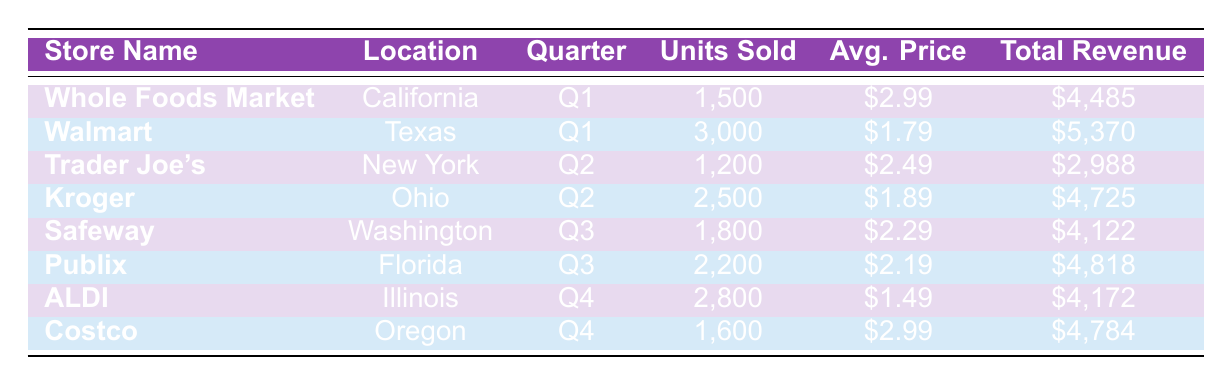What is the total revenue for Walmart in Q1? In the table, the row for Walmart in Q1 shows a total revenue of $5,370.
Answer: 5,370 Which store sold the highest number of units in Q3? By examining the rows for Q3, Publix sold 2,200 units while Safeway sold 1,800 units. Therefore, Publix sold more units than any other store in that quarter.
Answer: Publix What is the average price per unit for aubergines sold at Kroger in Q2? The table lists the average price per unit for Kroger in Q2 as $1.89.
Answer: 1.89 How many units were sold across all stores in Q4? For Q4, ALDI sold 2,800 units and Costco sold 1,600 units. Adding those figures, 2,800 + 1,600 equals 4,400 units sold in total during Q4.
Answer: 4,400 Is the average price per unit for aubergines sold at Whole Foods Market in Q1 higher than that at ALDI in Q4? Whole Foods Market had an average price of $2.99 in Q1, while ALDI's average price was $1.49 in Q4. Since $2.99 is greater than $1.49, the statement is true.
Answer: Yes What is the difference in total revenue between Trader Joe's and Kroger in Q2? Trader Joe's generated $2,988 in total revenue while Kroger had $4,725. Subtracting, $4,725 - $2,988 equals $1,737, which indicates Kroger earned more by this amount.
Answer: 1,737 Which store in California sold aubergines in 2023 and what was its total revenue? The only store listed in California is Whole Foods Market, which reported a total revenue of $4,485.
Answer: Whole Foods Market, 4,485 What was the average total revenue of the stores in Q1? In Q1, the total revenues of Whole Foods Market and Walmart were $4,485 and $5,370, respectively. Adding these gives $9,855, and averaging over 2 stores, we find $9,855 divided by 2 equals $4,927.5.
Answer: 4,927.5 